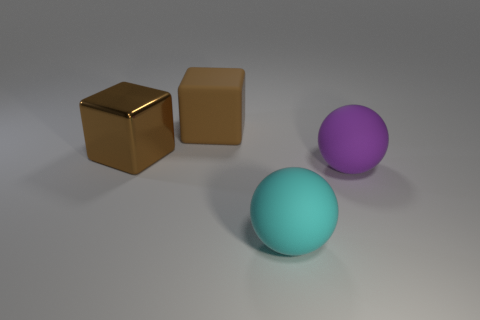Subtract all purple balls. How many balls are left? 1 Subtract 0 purple cylinders. How many objects are left? 4 Subtract 2 blocks. How many blocks are left? 0 Subtract all blue spheres. Subtract all purple cylinders. How many spheres are left? 2 Subtract all red cylinders. How many red cubes are left? 0 Subtract all small green metal cylinders. Subtract all big objects. How many objects are left? 0 Add 3 cyan things. How many cyan things are left? 4 Add 4 brown cubes. How many brown cubes exist? 6 Add 3 shiny objects. How many objects exist? 7 